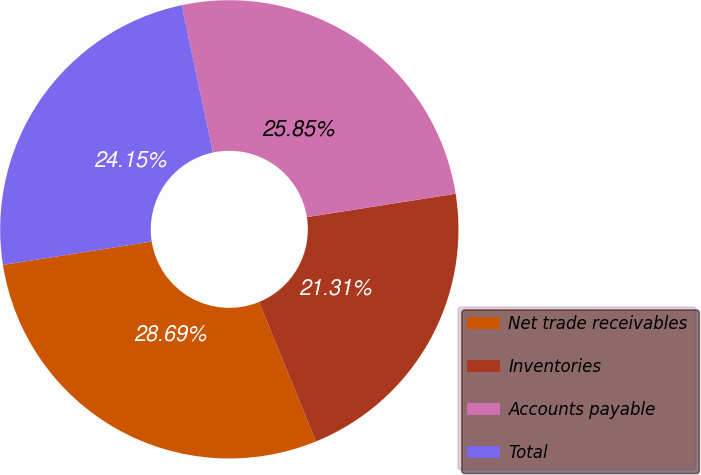<chart> <loc_0><loc_0><loc_500><loc_500><pie_chart><fcel>Net trade receivables<fcel>Inventories<fcel>Accounts payable<fcel>Total<nl><fcel>28.69%<fcel>21.31%<fcel>25.85%<fcel>24.15%<nl></chart> 